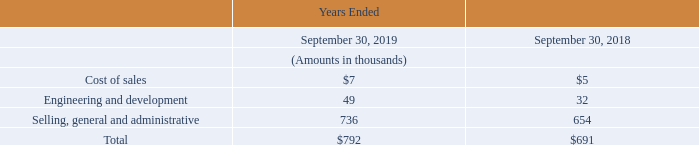The following table summarizes stock-based compensation expense in the Company’s consolidated statements of operations:
For the year ended September 30, 2019, the Company granted 33,000 nonvested shares to certain key employees, 55,000 nonvested shares to certain officers including 35,000 shares granted to the Chief Executive Officer, and 20,000 nonvested shares
to its non-employee directors. For the year ended September 30, 2018, the Company granted 12,000 nonvested shares to certain key employees, 40,000 nonvested shares to certain officers including 30,000 to its Chief Executive Officer and 20,000 nonvested
shares to its non-employee directors.
The Company measures the fair value of nonvested stock awards based upon the market price of its common stock as of the date of grant. The Company used the Black-Scholes option-pricing model to value stock options. The Black-Scholes model requires the use of a number of assumptions including volatility of the Company’s stock price, the weighted average risk-free interest rate and the weighted average expected life of the options, at the time of grant. The expected dividend yield is equal to the divided per share declared, divided by the closing share price on the date the options were granted. All equity compensation awards granted for the years ended September 30, 2019 and September 30, 2018 were nonvested stock awards.
How many nonvested shares did the company grant to key employees for the year ended September 30, 2019? 33,000. How does the company measure the value of the nonvested stock awards? Based upon the market price of its common stock as of the date of grant. What is the total stock based compensation expense incurred for the year ended September 30, 2019?
Answer scale should be: thousand. $792. What percentage of the total stock based compensation is spent on the cost of sales?
Answer scale should be: percent. $7/$792 
Answer: 0.88. What is the percentage increase in the stock based compensation expense on cost of sales?
Answer scale should be: percent. (7-5)/5 
Answer: 40. What is the total stock based compensation expense on non-cost of sales related activities?
Answer scale should be: thousand. 792 - 7 
Answer: 785. 